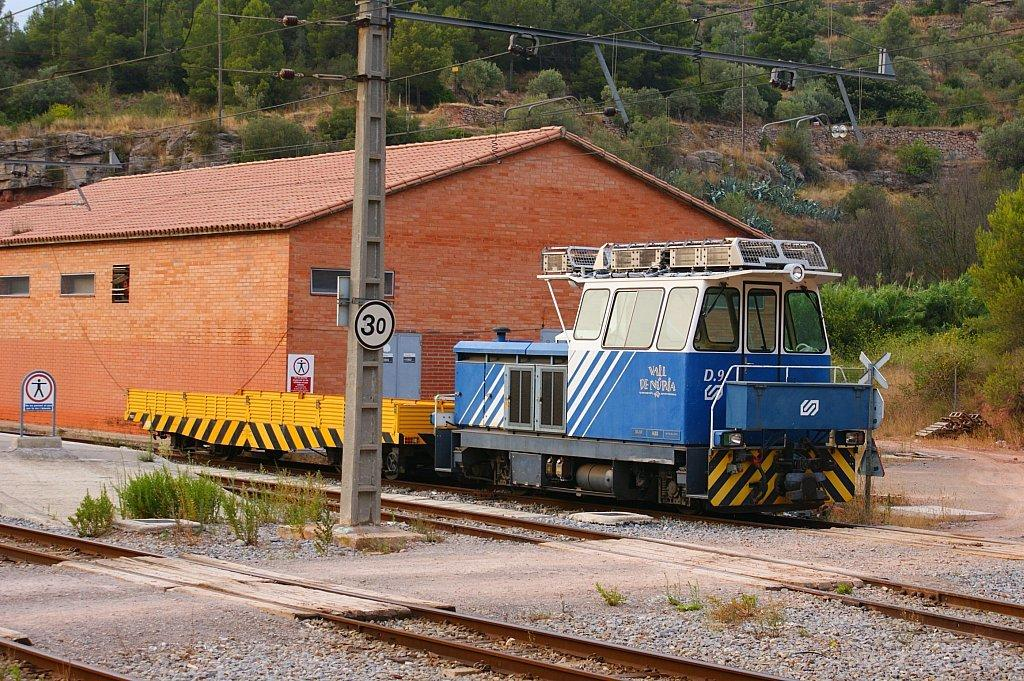What type of transportation infrastructure is visible in the image? There are railway tracks in the image. What structures are present alongside the railway tracks? There are boards and a shed visible in the image. What type of vegetation can be seen in the image? There are plants and trees in the image. What else can be seen in the image besides the railway tracks and vegetation? There are cables in the image. What type of seed is being sold in the shop in the image? There is no shop present in the image, so it is not possible to determine what type of seed might be sold. 